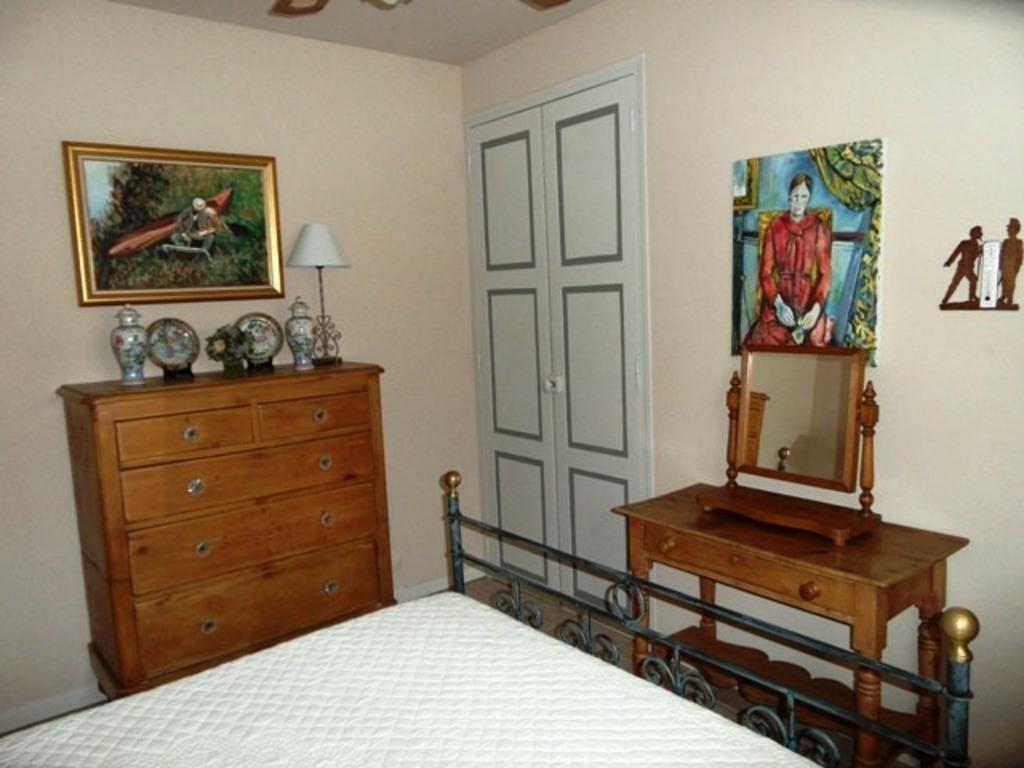What type of furniture is present in the image? There is a bed in the image. What object can be seen on a table in the image? There is a mirror on a table in the image. What type of decorations are on the wall in the image? There are photo frames on the wall in the image. What type of silk material is draped over the bed in the image? There is no silk material mentioned or visible in the image. Can you see any clams on the table with the mirror in the image? There are no clams present in the image; only a mirror is visible on the table. 